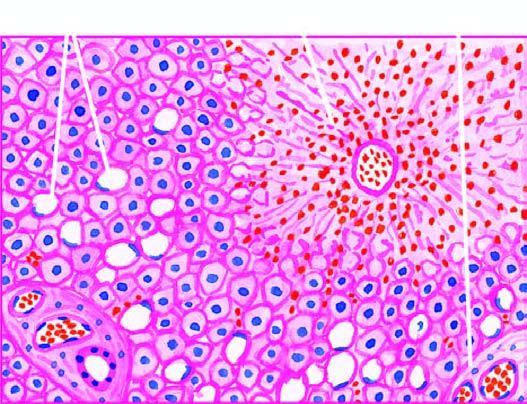what shows mild fatty change of liver cells?
Answer the question using a single word or phrase. The peripheral zone 